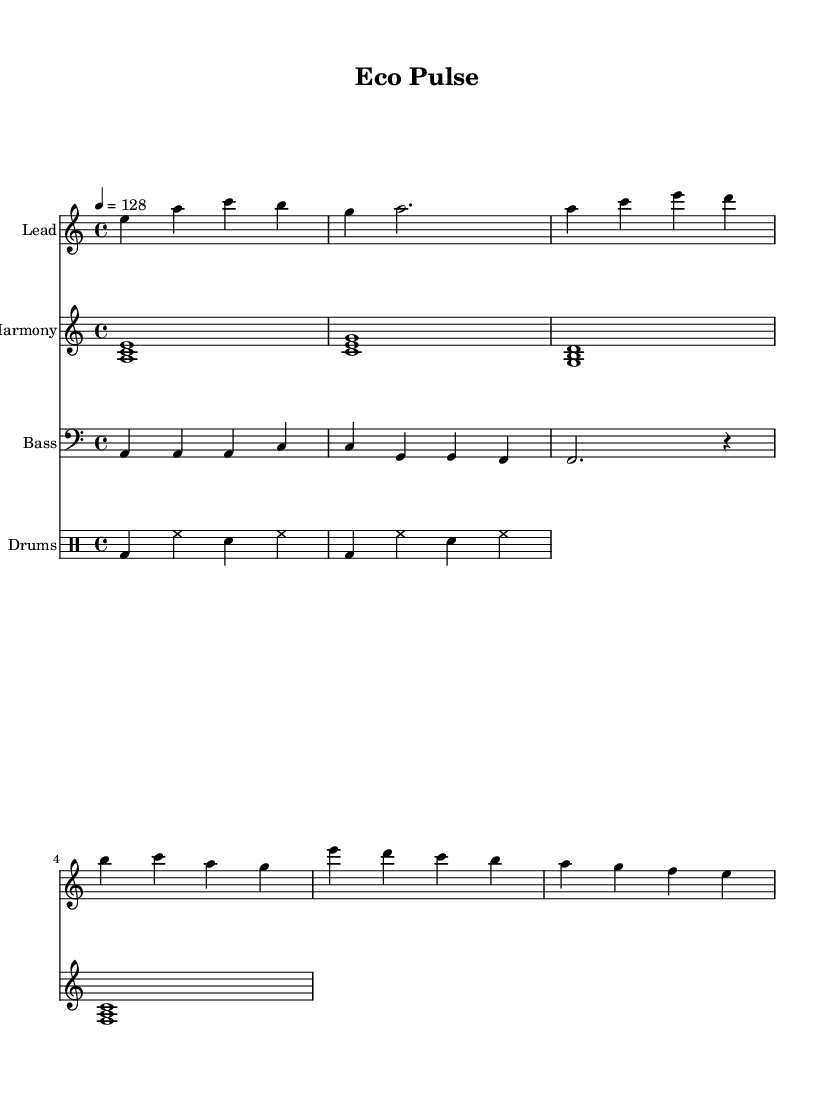What is the key signature of this music? The key signature is indicated by the sharp or flat symbols at the beginning of the staff. In this case, the music is in A minor, which has no sharps or flats.
Answer: A minor What is the time signature of this piece? The time signature is indicated at the beginning of the music, showing how many beats are in a measure. Here, it’s 4/4, meaning there are four beats per measure.
Answer: 4/4 What is the tempo marking of the sheet music? The tempo marking is indicated numerically above the staff; it tells the performer how fast to play the piece. Here, it is marked as 128 beats per minute.
Answer: 128 How many measures are in the melody section? To find the number of measures, count the combinations of notes and rests grouped together in the melody line. The melody shown has a total of four measures.
Answer: 4 What is the bass pattern of the music? The bass pattern can be identified in the bass clef sections of the music. In this case, the bass patterns primarily feature A and C notes.
Answer: A4, C, G How many different chord progressions are present in the harmony? Looking at the harmony staff, we can identify distinct chord progressions by counting the unique groupings of notes presented. There are four unique chord combinations in the pattern.
Answer: 4 What genre does this piece of music represent? The overall characteristics such as electronic beats and structured patterns indicate the genre. The title "Eco Pulse" and its environmental themes further suggest that it fits within the electronic dance music genre.
Answer: Electronic dance music 